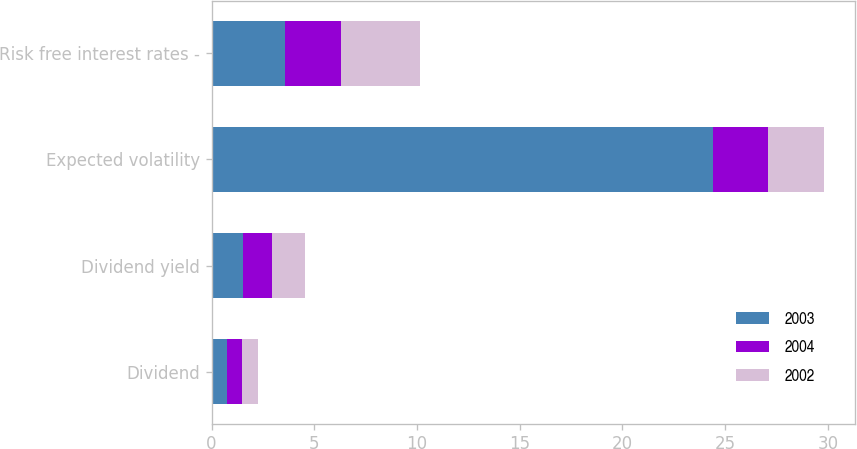Convert chart. <chart><loc_0><loc_0><loc_500><loc_500><stacked_bar_chart><ecel><fcel>Dividend<fcel>Dividend yield<fcel>Expected volatility<fcel>Risk free interest rates -<nl><fcel>2003<fcel>0.75<fcel>1.53<fcel>24.4<fcel>3.57<nl><fcel>2004<fcel>0.75<fcel>1.41<fcel>2.71<fcel>2.71<nl><fcel>2002<fcel>0.75<fcel>1.6<fcel>2.71<fcel>3.89<nl></chart> 